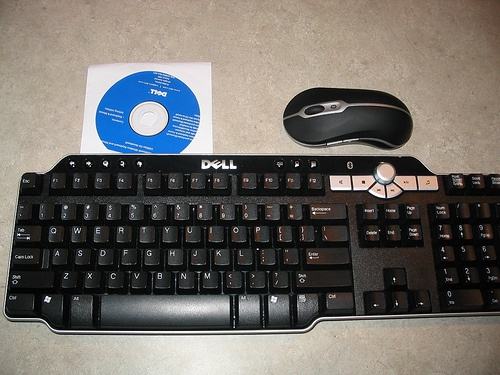Describe the objects in this image and their specific colors. I can see keyboard in gray, black, darkgray, and lightgray tones and mouse in gray, black, darkgray, and lightgray tones in this image. 